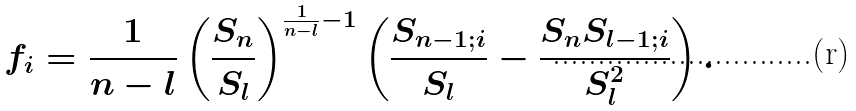<formula> <loc_0><loc_0><loc_500><loc_500>f _ { i } = \frac { 1 } { n - l } \left ( \frac { S _ { n } } { S _ { l } } \right ) ^ { \frac { 1 } { n - l } - 1 } \left ( \frac { S _ { n - 1 ; i } } { S _ { l } } - \frac { S _ { n } S _ { l - 1 ; i } } { S _ { l } ^ { 2 } } \right ) .</formula> 